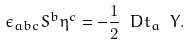Convert formula to latex. <formula><loc_0><loc_0><loc_500><loc_500>\epsilon _ { a b c } S ^ { b } \eta ^ { c } = - \frac { 1 } { 2 } \ D t _ { a } \ Y .</formula> 